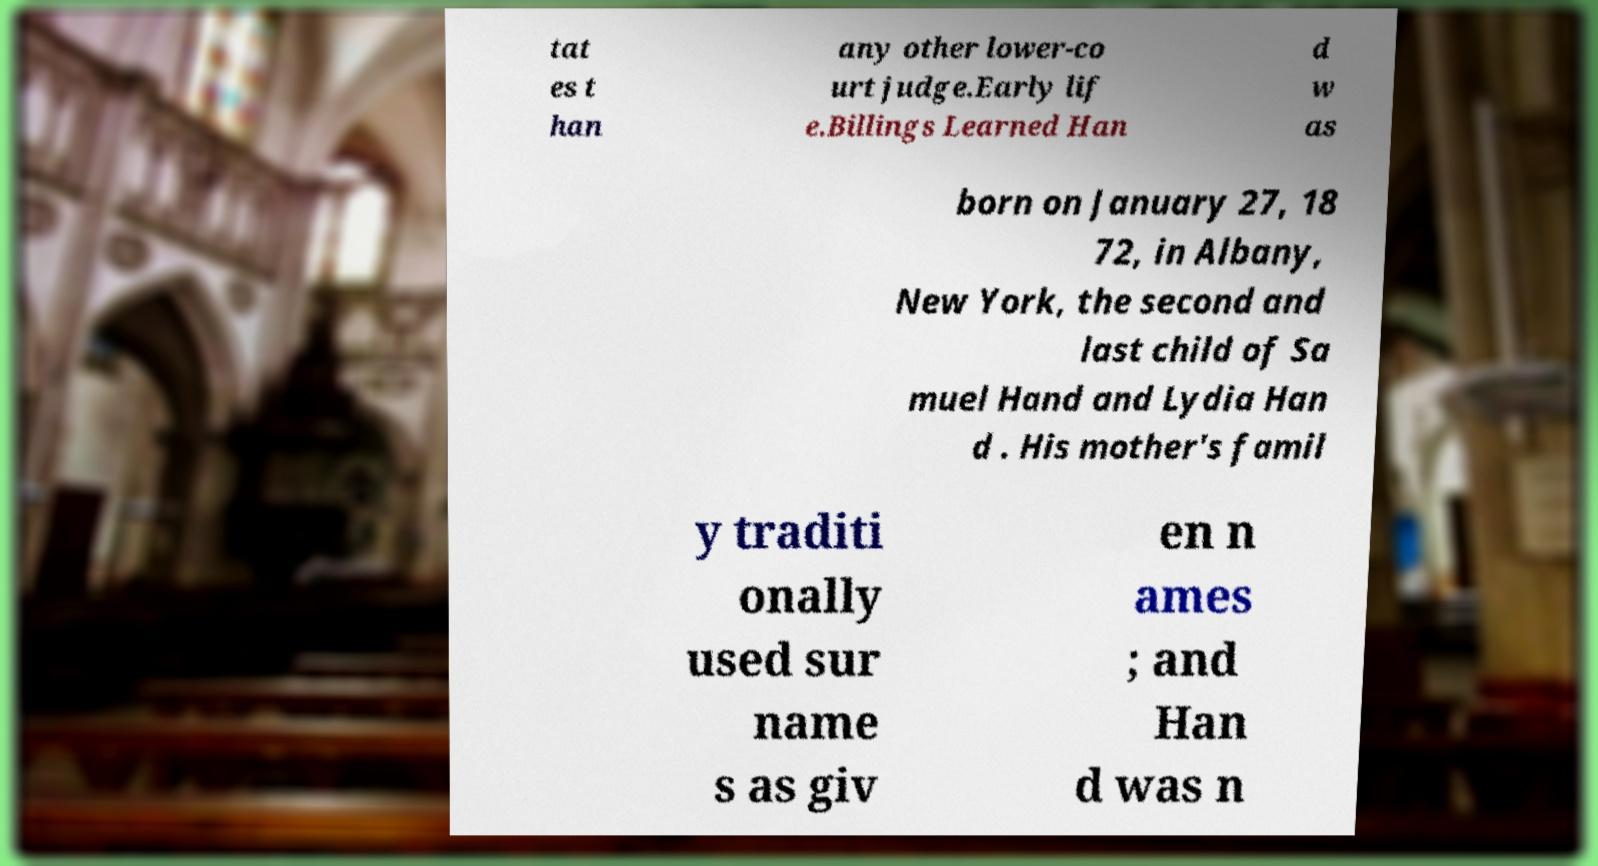Can you accurately transcribe the text from the provided image for me? tat es t han any other lower-co urt judge.Early lif e.Billings Learned Han d w as born on January 27, 18 72, in Albany, New York, the second and last child of Sa muel Hand and Lydia Han d . His mother's famil y traditi onally used sur name s as giv en n ames ; and Han d was n 